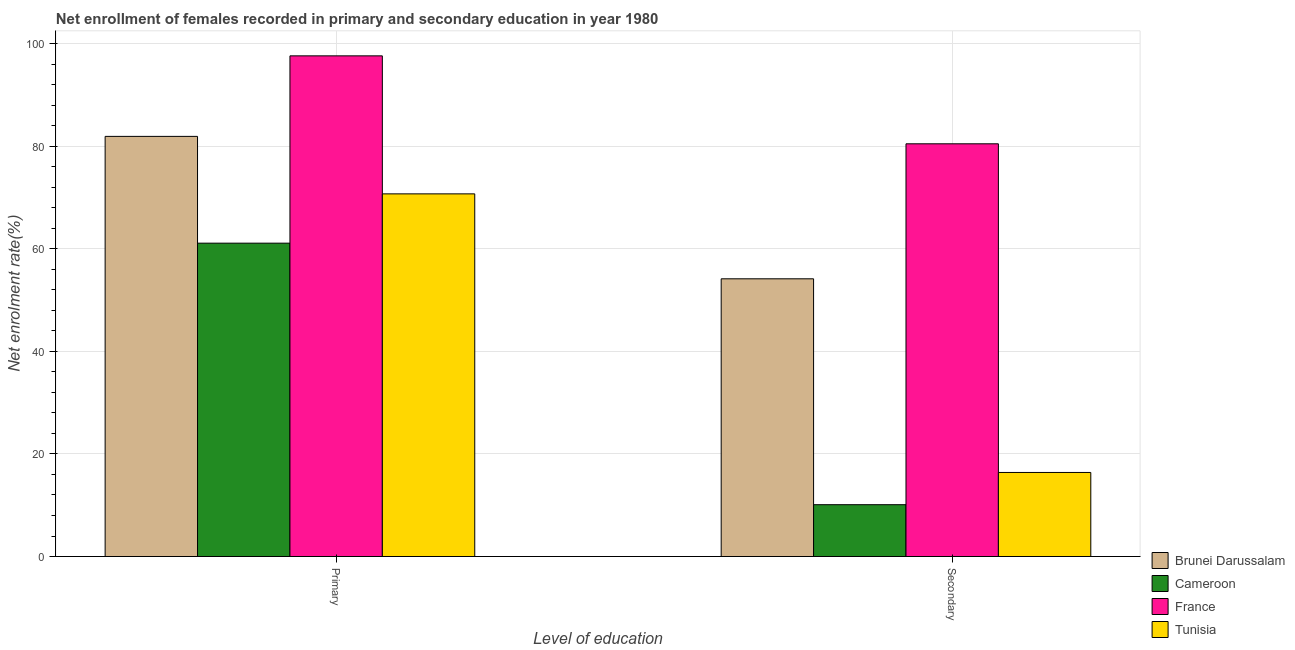How many groups of bars are there?
Your answer should be compact. 2. Are the number of bars per tick equal to the number of legend labels?
Offer a terse response. Yes. How many bars are there on the 1st tick from the left?
Your response must be concise. 4. What is the label of the 1st group of bars from the left?
Provide a succinct answer. Primary. What is the enrollment rate in secondary education in Tunisia?
Give a very brief answer. 16.39. Across all countries, what is the maximum enrollment rate in primary education?
Provide a succinct answer. 97.63. Across all countries, what is the minimum enrollment rate in secondary education?
Offer a terse response. 10.11. In which country was the enrollment rate in primary education minimum?
Keep it short and to the point. Cameroon. What is the total enrollment rate in primary education in the graph?
Your response must be concise. 311.39. What is the difference between the enrollment rate in primary education in Brunei Darussalam and that in France?
Your response must be concise. -15.7. What is the difference between the enrollment rate in secondary education in France and the enrollment rate in primary education in Brunei Darussalam?
Your answer should be compact. -1.45. What is the average enrollment rate in secondary education per country?
Offer a terse response. 40.29. What is the difference between the enrollment rate in primary education and enrollment rate in secondary education in Tunisia?
Your answer should be very brief. 54.33. What is the ratio of the enrollment rate in secondary education in Cameroon to that in France?
Your answer should be very brief. 0.13. In how many countries, is the enrollment rate in primary education greater than the average enrollment rate in primary education taken over all countries?
Your response must be concise. 2. What does the 4th bar from the left in Secondary represents?
Offer a terse response. Tunisia. What does the 4th bar from the right in Secondary represents?
Give a very brief answer. Brunei Darussalam. How many bars are there?
Make the answer very short. 8. What is the difference between two consecutive major ticks on the Y-axis?
Your response must be concise. 20. Where does the legend appear in the graph?
Your response must be concise. Bottom right. What is the title of the graph?
Your answer should be very brief. Net enrollment of females recorded in primary and secondary education in year 1980. What is the label or title of the X-axis?
Your answer should be compact. Level of education. What is the label or title of the Y-axis?
Make the answer very short. Net enrolment rate(%). What is the Net enrolment rate(%) in Brunei Darussalam in Primary?
Ensure brevity in your answer.  81.93. What is the Net enrolment rate(%) in Cameroon in Primary?
Give a very brief answer. 61.11. What is the Net enrolment rate(%) of France in Primary?
Ensure brevity in your answer.  97.63. What is the Net enrolment rate(%) of Tunisia in Primary?
Make the answer very short. 70.72. What is the Net enrolment rate(%) in Brunei Darussalam in Secondary?
Keep it short and to the point. 54.16. What is the Net enrolment rate(%) in Cameroon in Secondary?
Offer a very short reply. 10.11. What is the Net enrolment rate(%) in France in Secondary?
Keep it short and to the point. 80.48. What is the Net enrolment rate(%) in Tunisia in Secondary?
Make the answer very short. 16.39. Across all Level of education, what is the maximum Net enrolment rate(%) in Brunei Darussalam?
Offer a terse response. 81.93. Across all Level of education, what is the maximum Net enrolment rate(%) in Cameroon?
Provide a succinct answer. 61.11. Across all Level of education, what is the maximum Net enrolment rate(%) in France?
Your response must be concise. 97.63. Across all Level of education, what is the maximum Net enrolment rate(%) of Tunisia?
Give a very brief answer. 70.72. Across all Level of education, what is the minimum Net enrolment rate(%) in Brunei Darussalam?
Provide a short and direct response. 54.16. Across all Level of education, what is the minimum Net enrolment rate(%) in Cameroon?
Offer a very short reply. 10.11. Across all Level of education, what is the minimum Net enrolment rate(%) of France?
Your answer should be very brief. 80.48. Across all Level of education, what is the minimum Net enrolment rate(%) in Tunisia?
Make the answer very short. 16.39. What is the total Net enrolment rate(%) of Brunei Darussalam in the graph?
Ensure brevity in your answer.  136.09. What is the total Net enrolment rate(%) of Cameroon in the graph?
Make the answer very short. 71.22. What is the total Net enrolment rate(%) in France in the graph?
Your response must be concise. 178.12. What is the total Net enrolment rate(%) in Tunisia in the graph?
Your answer should be very brief. 87.11. What is the difference between the Net enrolment rate(%) of Brunei Darussalam in Primary and that in Secondary?
Offer a terse response. 27.77. What is the difference between the Net enrolment rate(%) of Cameroon in Primary and that in Secondary?
Provide a short and direct response. 51. What is the difference between the Net enrolment rate(%) of France in Primary and that in Secondary?
Make the answer very short. 17.15. What is the difference between the Net enrolment rate(%) in Tunisia in Primary and that in Secondary?
Your answer should be compact. 54.33. What is the difference between the Net enrolment rate(%) of Brunei Darussalam in Primary and the Net enrolment rate(%) of Cameroon in Secondary?
Give a very brief answer. 71.82. What is the difference between the Net enrolment rate(%) of Brunei Darussalam in Primary and the Net enrolment rate(%) of France in Secondary?
Keep it short and to the point. 1.45. What is the difference between the Net enrolment rate(%) in Brunei Darussalam in Primary and the Net enrolment rate(%) in Tunisia in Secondary?
Offer a very short reply. 65.54. What is the difference between the Net enrolment rate(%) of Cameroon in Primary and the Net enrolment rate(%) of France in Secondary?
Ensure brevity in your answer.  -19.38. What is the difference between the Net enrolment rate(%) of Cameroon in Primary and the Net enrolment rate(%) of Tunisia in Secondary?
Provide a succinct answer. 44.71. What is the difference between the Net enrolment rate(%) of France in Primary and the Net enrolment rate(%) of Tunisia in Secondary?
Offer a very short reply. 81.24. What is the average Net enrolment rate(%) of Brunei Darussalam per Level of education?
Provide a succinct answer. 68.04. What is the average Net enrolment rate(%) in Cameroon per Level of education?
Make the answer very short. 35.61. What is the average Net enrolment rate(%) in France per Level of education?
Your answer should be compact. 89.06. What is the average Net enrolment rate(%) of Tunisia per Level of education?
Keep it short and to the point. 43.56. What is the difference between the Net enrolment rate(%) of Brunei Darussalam and Net enrolment rate(%) of Cameroon in Primary?
Your answer should be very brief. 20.82. What is the difference between the Net enrolment rate(%) of Brunei Darussalam and Net enrolment rate(%) of France in Primary?
Your answer should be compact. -15.7. What is the difference between the Net enrolment rate(%) in Brunei Darussalam and Net enrolment rate(%) in Tunisia in Primary?
Ensure brevity in your answer.  11.21. What is the difference between the Net enrolment rate(%) of Cameroon and Net enrolment rate(%) of France in Primary?
Ensure brevity in your answer.  -36.52. What is the difference between the Net enrolment rate(%) of Cameroon and Net enrolment rate(%) of Tunisia in Primary?
Provide a short and direct response. -9.61. What is the difference between the Net enrolment rate(%) of France and Net enrolment rate(%) of Tunisia in Primary?
Offer a terse response. 26.91. What is the difference between the Net enrolment rate(%) in Brunei Darussalam and Net enrolment rate(%) in Cameroon in Secondary?
Offer a very short reply. 44.05. What is the difference between the Net enrolment rate(%) of Brunei Darussalam and Net enrolment rate(%) of France in Secondary?
Provide a short and direct response. -26.33. What is the difference between the Net enrolment rate(%) of Brunei Darussalam and Net enrolment rate(%) of Tunisia in Secondary?
Offer a terse response. 37.76. What is the difference between the Net enrolment rate(%) of Cameroon and Net enrolment rate(%) of France in Secondary?
Offer a very short reply. -70.38. What is the difference between the Net enrolment rate(%) of Cameroon and Net enrolment rate(%) of Tunisia in Secondary?
Provide a succinct answer. -6.28. What is the difference between the Net enrolment rate(%) of France and Net enrolment rate(%) of Tunisia in Secondary?
Offer a very short reply. 64.09. What is the ratio of the Net enrolment rate(%) in Brunei Darussalam in Primary to that in Secondary?
Provide a short and direct response. 1.51. What is the ratio of the Net enrolment rate(%) in Cameroon in Primary to that in Secondary?
Ensure brevity in your answer.  6.05. What is the ratio of the Net enrolment rate(%) of France in Primary to that in Secondary?
Keep it short and to the point. 1.21. What is the ratio of the Net enrolment rate(%) of Tunisia in Primary to that in Secondary?
Your response must be concise. 4.31. What is the difference between the highest and the second highest Net enrolment rate(%) of Brunei Darussalam?
Your answer should be very brief. 27.77. What is the difference between the highest and the second highest Net enrolment rate(%) of Cameroon?
Offer a very short reply. 51. What is the difference between the highest and the second highest Net enrolment rate(%) in France?
Give a very brief answer. 17.15. What is the difference between the highest and the second highest Net enrolment rate(%) of Tunisia?
Your answer should be compact. 54.33. What is the difference between the highest and the lowest Net enrolment rate(%) in Brunei Darussalam?
Provide a short and direct response. 27.77. What is the difference between the highest and the lowest Net enrolment rate(%) of Cameroon?
Provide a short and direct response. 51. What is the difference between the highest and the lowest Net enrolment rate(%) in France?
Make the answer very short. 17.15. What is the difference between the highest and the lowest Net enrolment rate(%) in Tunisia?
Give a very brief answer. 54.33. 